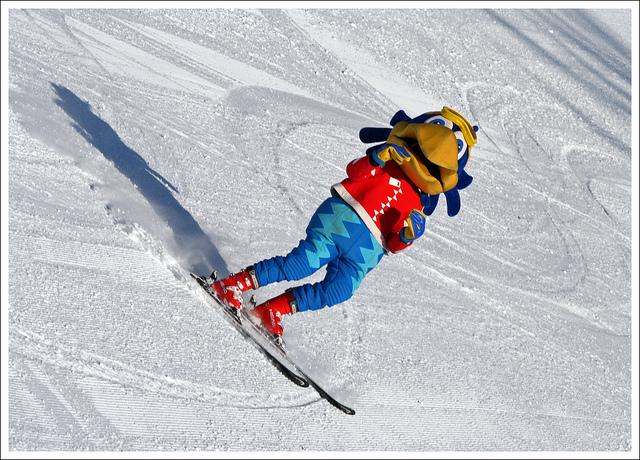Is this normal dress for skiing?
Be succinct. No. Is it carnival?
Give a very brief answer. No. What are the swirls in the snow from?
Keep it brief. Skis. 